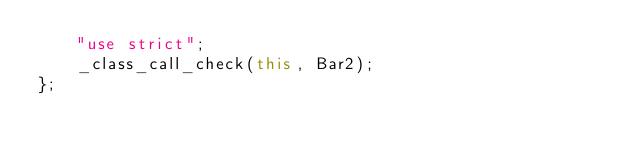Convert code to text. <code><loc_0><loc_0><loc_500><loc_500><_JavaScript_>    "use strict";
    _class_call_check(this, Bar2);
};
</code> 